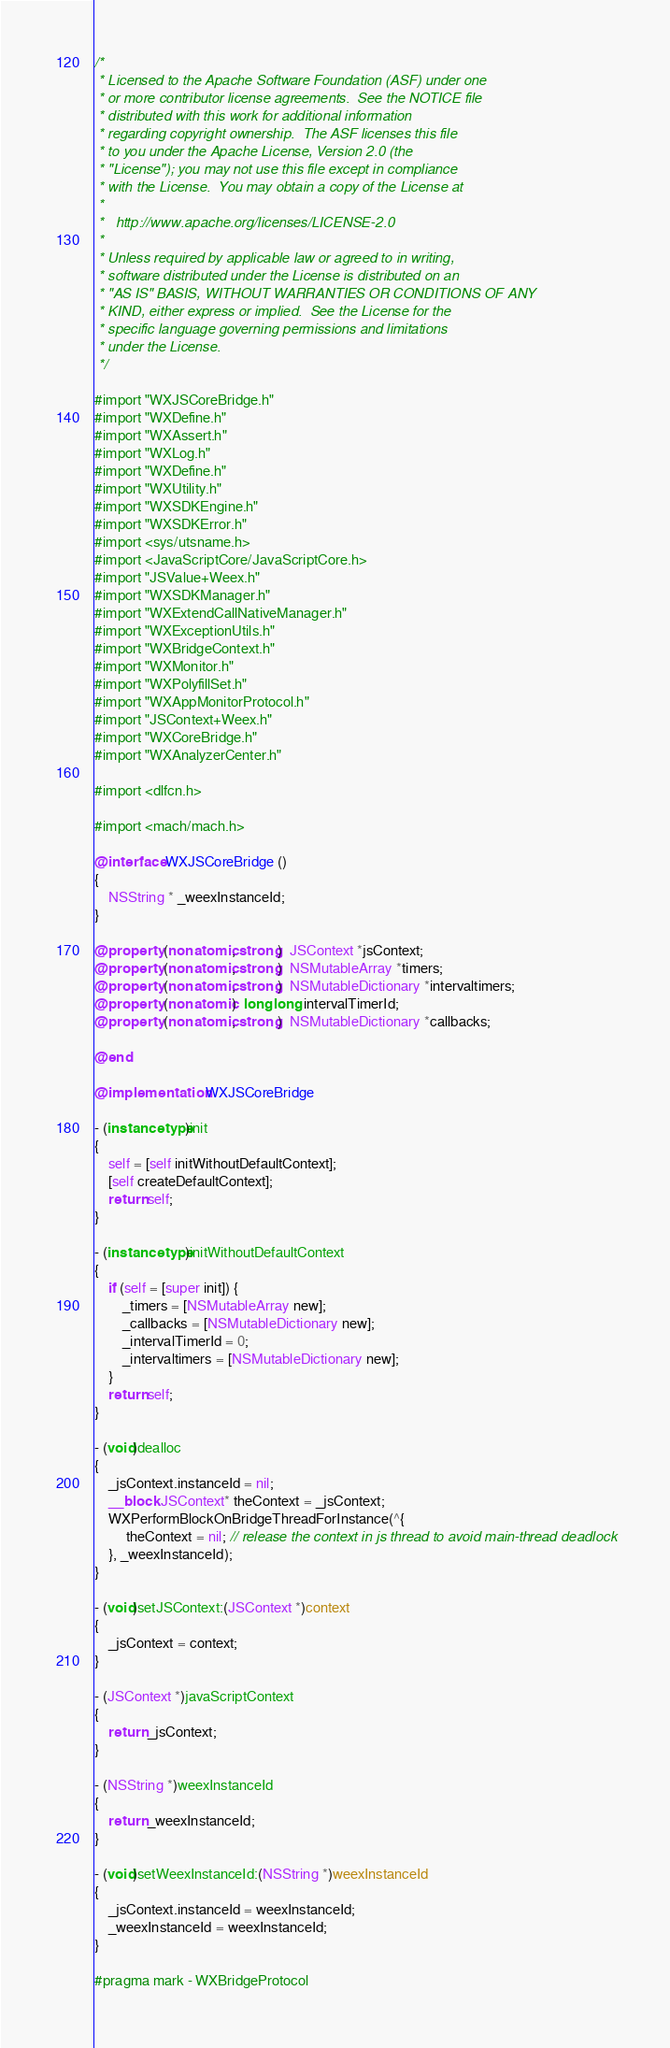Convert code to text. <code><loc_0><loc_0><loc_500><loc_500><_ObjectiveC_>/*
 * Licensed to the Apache Software Foundation (ASF) under one
 * or more contributor license agreements.  See the NOTICE file
 * distributed with this work for additional information
 * regarding copyright ownership.  The ASF licenses this file
 * to you under the Apache License, Version 2.0 (the
 * "License"); you may not use this file except in compliance
 * with the License.  You may obtain a copy of the License at
 * 
 *   http://www.apache.org/licenses/LICENSE-2.0
 * 
 * Unless required by applicable law or agreed to in writing,
 * software distributed under the License is distributed on an
 * "AS IS" BASIS, WITHOUT WARRANTIES OR CONDITIONS OF ANY
 * KIND, either express or implied.  See the License for the
 * specific language governing permissions and limitations
 * under the License.
 */

#import "WXJSCoreBridge.h"
#import "WXDefine.h"
#import "WXAssert.h"
#import "WXLog.h"
#import "WXDefine.h"
#import "WXUtility.h"
#import "WXSDKEngine.h"
#import "WXSDKError.h"
#import <sys/utsname.h>
#import <JavaScriptCore/JavaScriptCore.h>
#import "JSValue+Weex.h"
#import "WXSDKManager.h"
#import "WXExtendCallNativeManager.h"
#import "WXExceptionUtils.h"
#import "WXBridgeContext.h"
#import "WXMonitor.h"
#import "WXPolyfillSet.h"
#import "WXAppMonitorProtocol.h"
#import "JSContext+Weex.h"
#import "WXCoreBridge.h"
#import "WXAnalyzerCenter.h"

#import <dlfcn.h>

#import <mach/mach.h>

@interface WXJSCoreBridge ()
{
    NSString * _weexInstanceId;
}

@property (nonatomic, strong)  JSContext *jsContext;
@property (nonatomic, strong)  NSMutableArray *timers;
@property (nonatomic, strong)  NSMutableDictionary *intervaltimers;
@property (nonatomic)  long long intervalTimerId;
@property (nonatomic, strong)  NSMutableDictionary *callbacks;

@end

@implementation WXJSCoreBridge

- (instancetype)init
{
    self = [self initWithoutDefaultContext];
    [self createDefaultContext];
    return self;
}

- (instancetype)initWithoutDefaultContext
{
    if (self = [super init]) {
        _timers = [NSMutableArray new];
        _callbacks = [NSMutableDictionary new];
        _intervalTimerId = 0;
        _intervaltimers = [NSMutableDictionary new];
    }
    return self;
}

- (void)dealloc
{
    _jsContext.instanceId = nil;
    __block JSContext* theContext = _jsContext;
    WXPerformBlockOnBridgeThreadForInstance(^{
         theContext = nil; // release the context in js thread to avoid main-thread deadlock
    }, _weexInstanceId);
}

- (void)setJSContext:(JSContext *)context
{
    _jsContext = context;
}

- (JSContext *)javaScriptContext
{
    return _jsContext;
}

- (NSString *)weexInstanceId
{
    return _weexInstanceId;
}

- (void)setWeexInstanceId:(NSString *)weexInstanceId
{
    _jsContext.instanceId = weexInstanceId;
    _weexInstanceId = weexInstanceId;
}

#pragma mark - WXBridgeProtocol
</code> 